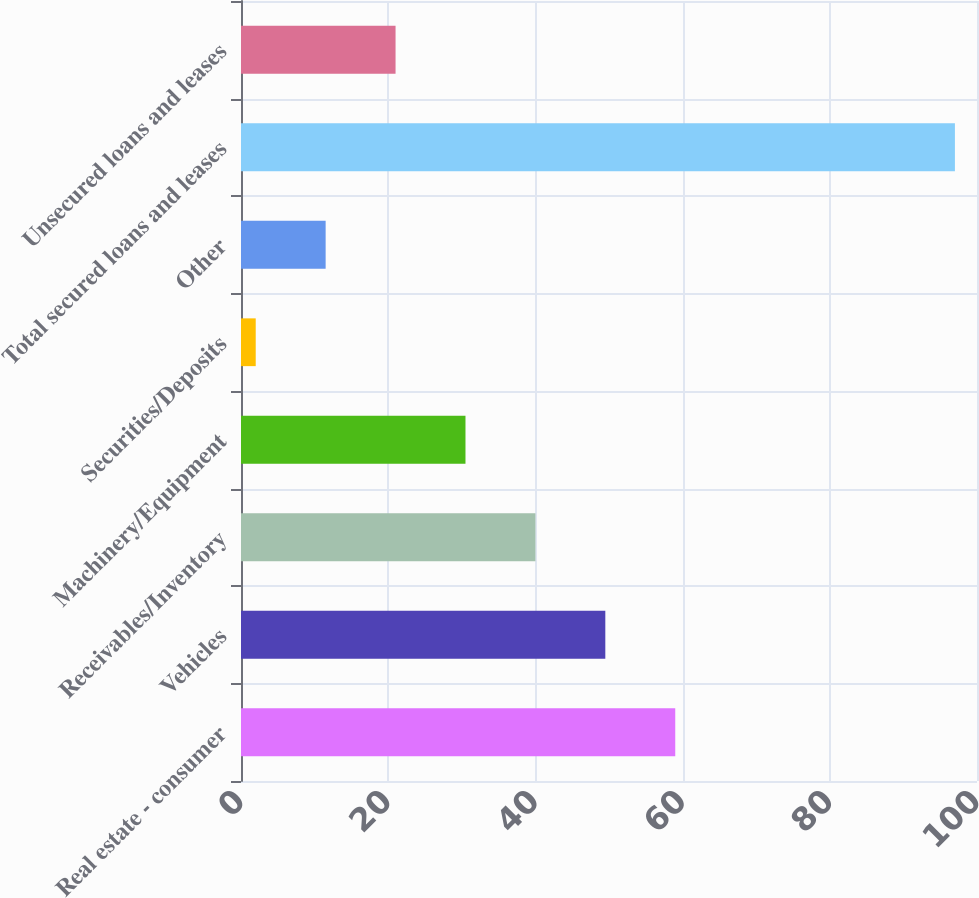Convert chart. <chart><loc_0><loc_0><loc_500><loc_500><bar_chart><fcel>Real estate - consumer<fcel>Vehicles<fcel>Receivables/Inventory<fcel>Machinery/Equipment<fcel>Securities/Deposits<fcel>Other<fcel>Total secured loans and leases<fcel>Unsecured loans and leases<nl><fcel>59<fcel>49.5<fcel>40<fcel>30.5<fcel>2<fcel>11.5<fcel>97<fcel>21<nl></chart> 